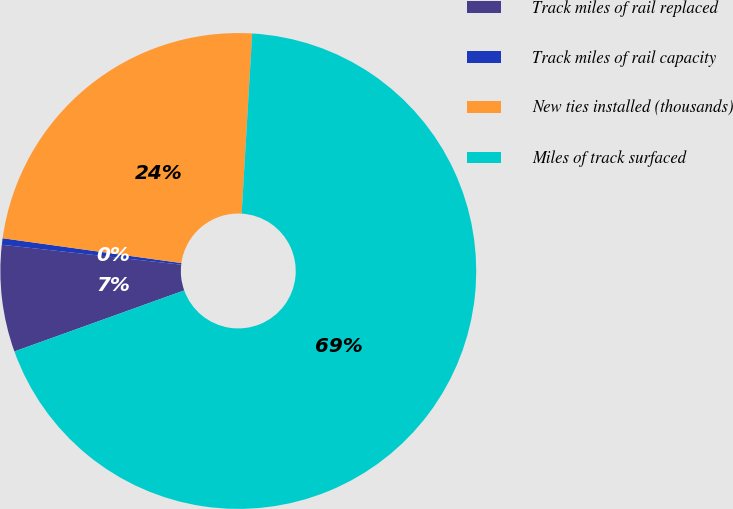<chart> <loc_0><loc_0><loc_500><loc_500><pie_chart><fcel>Track miles of rail replaced<fcel>Track miles of rail capacity<fcel>New ties installed (thousands)<fcel>Miles of track surfaced<nl><fcel>7.25%<fcel>0.44%<fcel>23.73%<fcel>68.57%<nl></chart> 